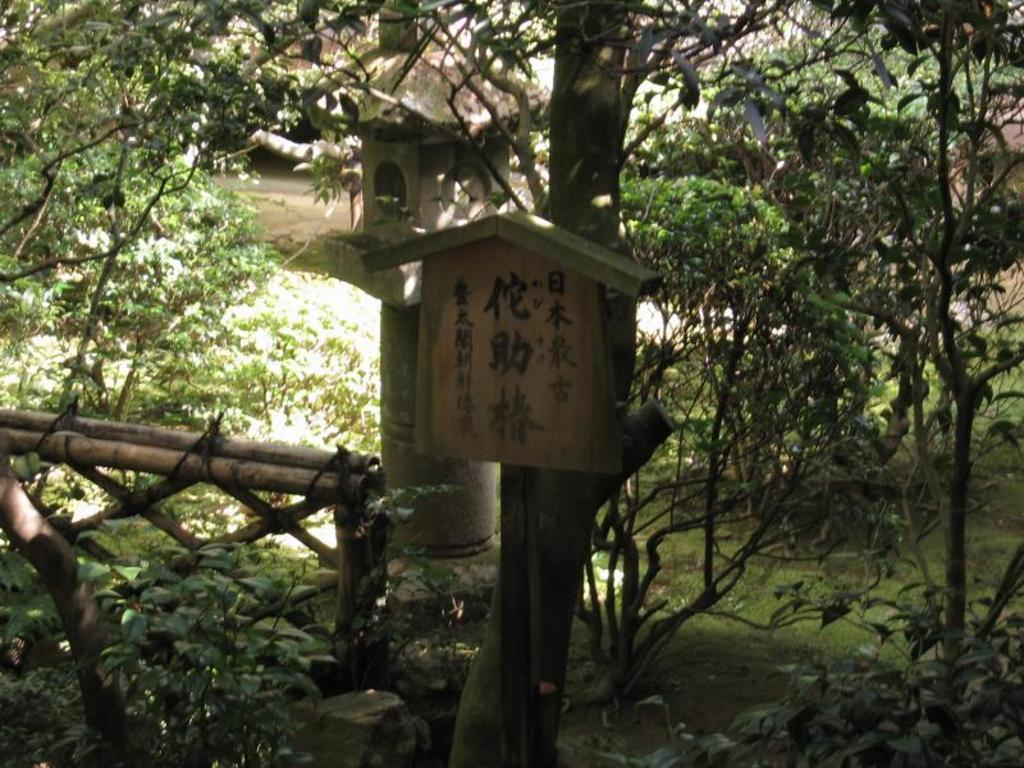What structure is present in the image for birds? There is a bird house in the image. What is located in front of the bird house? There is a wooden fence in front of the bird house. What wooden object can be seen on a tree in the image? There is a wooden object on a tree in the image. What type of vegetation is visible behind the bird house? There are trees visible behind the bird house. Where is the store located in the image? There is no store present in the image. What type of bead can be seen hanging from the bird house? There are no beads visible in the image, and no beads are mentioned in the provided facts. 